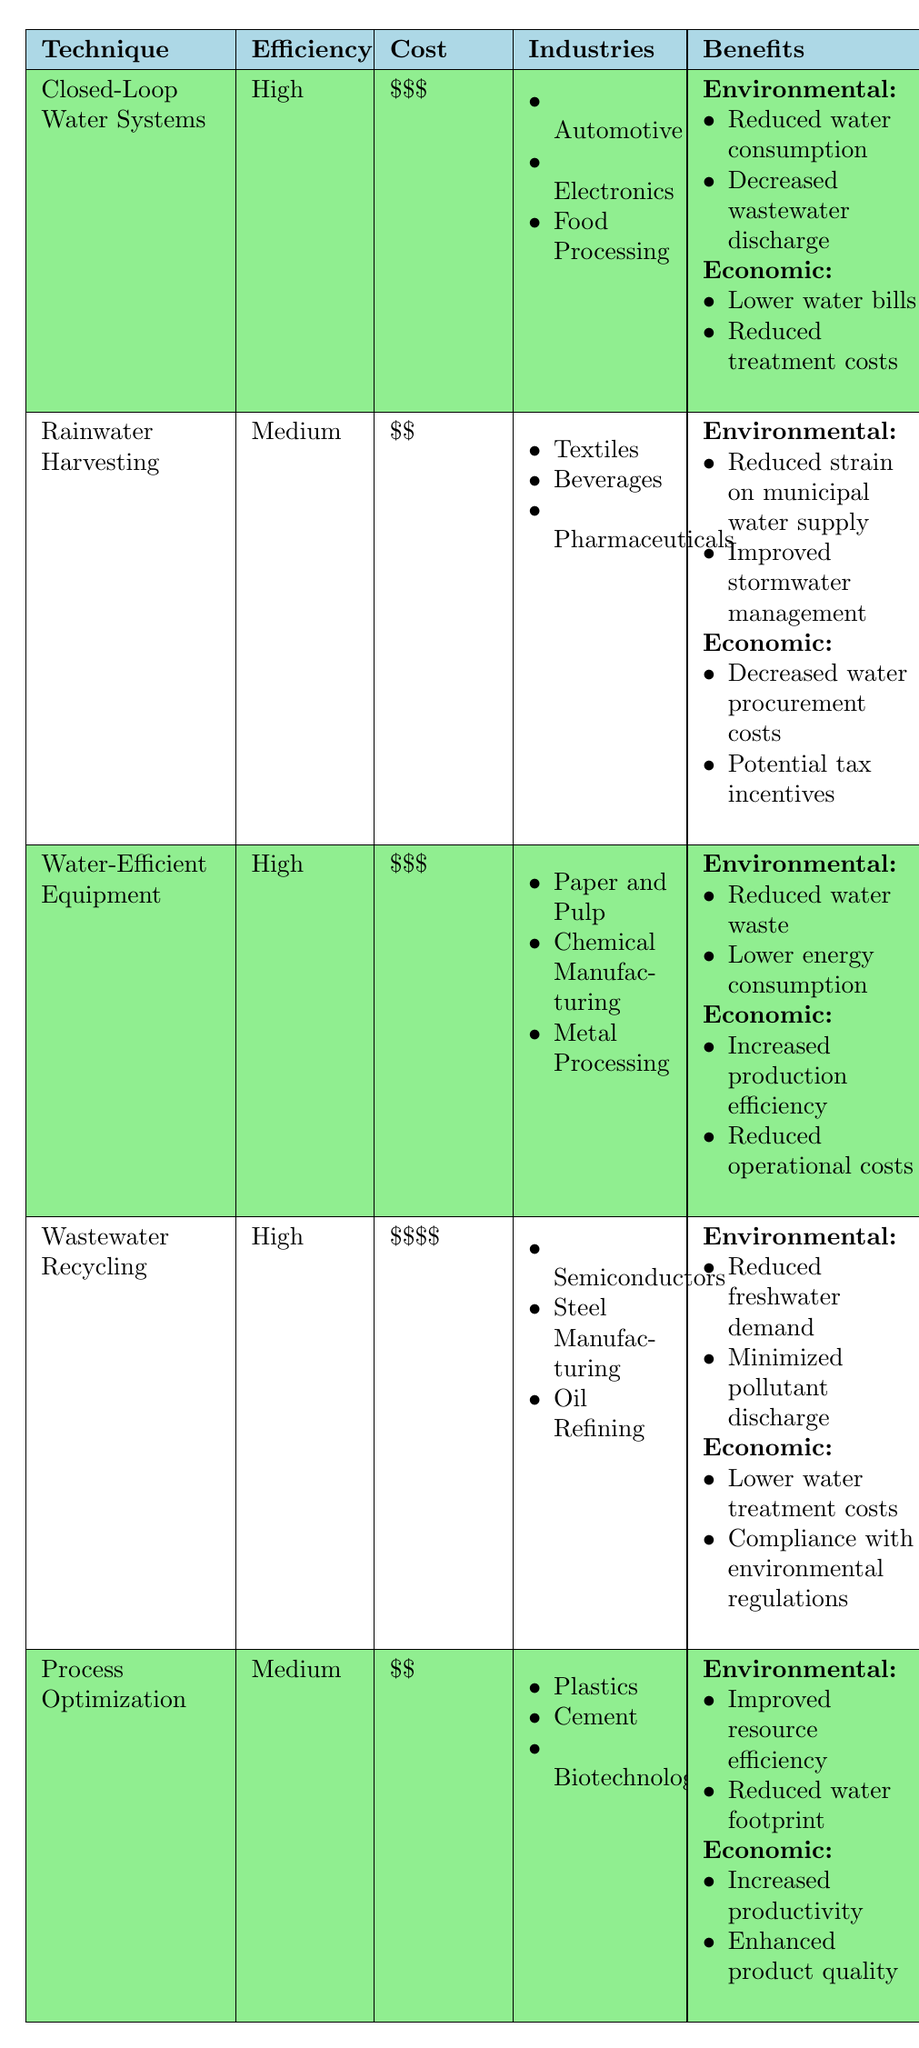What is the implementation cost of Wastewater Recycling? The table specifies the implementation cost for Wastewater Recycling as "$$$$".
Answer: $$$$ Which company had a 61% reduction in water use per vehicle? The table shows that Toyota Motor Corporation achieved a 61% reduction in water use per vehicle for the Closed-Loop Water Systems technique.
Answer: Toyota Motor Corporation Which water conservation technique has the highest efficiency? Comparing the efficiency ratings in the table, both Closed-Loop Water Systems and Wastewater Recycling have a high efficiency rating.
Answer: Closed-Loop Water Systems and Wastewater Recycling What type of industries can benefit from Rainwater Harvesting? The table lists the industries benefiting from Rainwater Harvesting as Textiles, Beverages, and Pharmaceuticals.
Answer: Textiles, Beverages, Pharmaceuticals True or False: Water-Efficient Equipment is a technique used in Automotive industries. The table does not list Automotive under the industries for Water-Efficient Equipment; it lists Paper and Pulp, Chemical Manufacturing, and Metal Processing.
Answer: False What are the environmental benefits of implementing Wastewater Recycling? The environmental benefits listed for Wastewater Recycling in the table are reduced freshwater demand and minimized pollutant discharge.
Answer: Reduced freshwater demand and minimized pollutant discharge What is the total number of water saving case studies noted in the table? There are five techniques listed in the table, each with one corresponding case study, resulting in a total of 5 water saving case studies.
Answer: 5 Which technique has a lower implementation cost, Closed-Loop Water Systems or Wastewater Recycling? Closed-Loop Water Systems has an implementation cost of "$$$", while Wastewater Recycling costs "$$$$", indicating that Closed-Loop Water Systems is cheaper.
Answer: Closed-Loop Water Systems Which technique provides the most significant annual water savings mentioned in the case studies? The case study for Wastewater Recycling shows a water savings of 4.5 billion gallons annually, which is the highest among all techniques listed.
Answer: Wastewater Recycling If we consider only techniques with high efficiency, how many industries are listed under Water-Efficient Equipment? Water-Efficient Equipment has three industries listed: Paper and Pulp, Chemical Manufacturing, and Metal Processing. Therefore, the total is 3 industries.
Answer: 3 